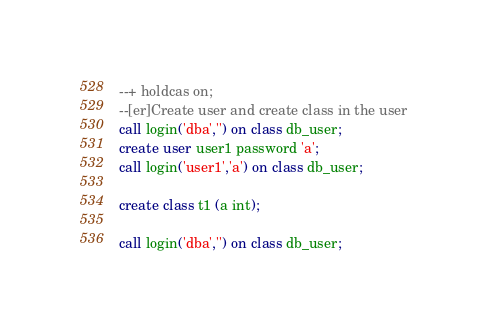<code> <loc_0><loc_0><loc_500><loc_500><_SQL_>--+ holdcas on;
--[er]Create user and create class in the user 
call login('dba','') on class db_user;
create user user1 password 'a';
call login('user1','a') on class db_user;

create class t1 (a int);

call login('dba','') on class db_user;</code> 